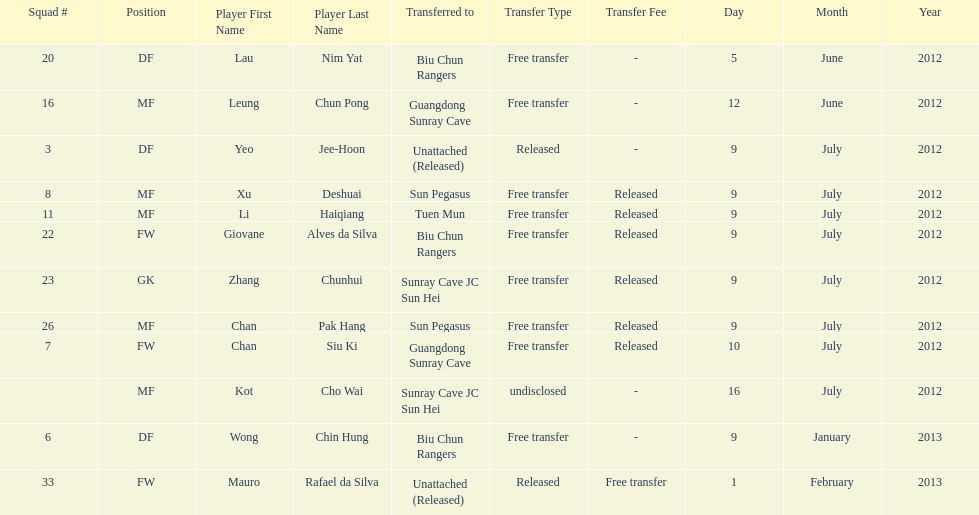Player transferred immediately before mauro rafael da silva Wong Chin Hung. Could you parse the entire table as a dict? {'header': ['Squad #', 'Position', 'Player First Name', 'Player Last Name', 'Transferred to', 'Transfer Type', 'Transfer Fee', 'Day', 'Month', 'Year'], 'rows': [['20', 'DF', 'Lau', 'Nim Yat', 'Biu Chun Rangers', 'Free transfer', '-', '5', 'June', '2012'], ['16', 'MF', 'Leung', 'Chun Pong', 'Guangdong Sunray Cave', 'Free transfer', '-', '12', 'June', '2012'], ['3', 'DF', 'Yeo', 'Jee-Hoon', 'Unattached (Released)', 'Released', '-', '9', 'July', '2012'], ['8', 'MF', 'Xu', 'Deshuai', 'Sun Pegasus', 'Free transfer', 'Released', '9', 'July', '2012'], ['11', 'MF', 'Li', 'Haiqiang', 'Tuen Mun', 'Free transfer', 'Released', '9', 'July', '2012'], ['22', 'FW', 'Giovane', 'Alves da Silva', 'Biu Chun Rangers', 'Free transfer', 'Released', '9', 'July', '2012'], ['23', 'GK', 'Zhang', 'Chunhui', 'Sunray Cave JC Sun Hei', 'Free transfer', 'Released', '9', 'July', '2012'], ['26', 'MF', 'Chan', 'Pak Hang', 'Sun Pegasus', 'Free transfer', 'Released', '9', 'July', '2012'], ['7', 'FW', 'Chan', 'Siu Ki', 'Guangdong Sunray Cave', 'Free transfer', 'Released', '10', 'July', '2012'], ['', 'MF', 'Kot', 'Cho Wai', 'Sunray Cave JC Sun Hei', 'undisclosed', '-', '16', 'July', '2012'], ['6', 'DF', 'Wong', 'Chin Hung', 'Biu Chun Rangers', 'Free transfer', '-', '9', 'January', '2013'], ['33', 'FW', 'Mauro', 'Rafael da Silva', 'Unattached (Released)', 'Released', 'Free transfer', '1', 'February', '2013']]} 